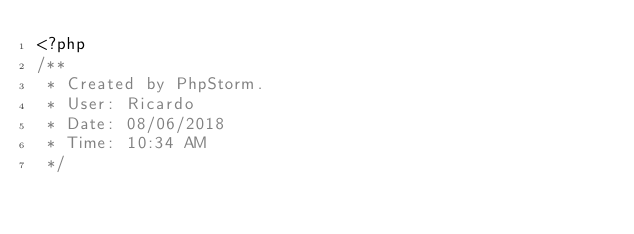Convert code to text. <code><loc_0><loc_0><loc_500><loc_500><_PHP_><?php
/**
 * Created by PhpStorm.
 * User: Ricardo
 * Date: 08/06/2018
 * Time: 10:34 AM
 */</code> 